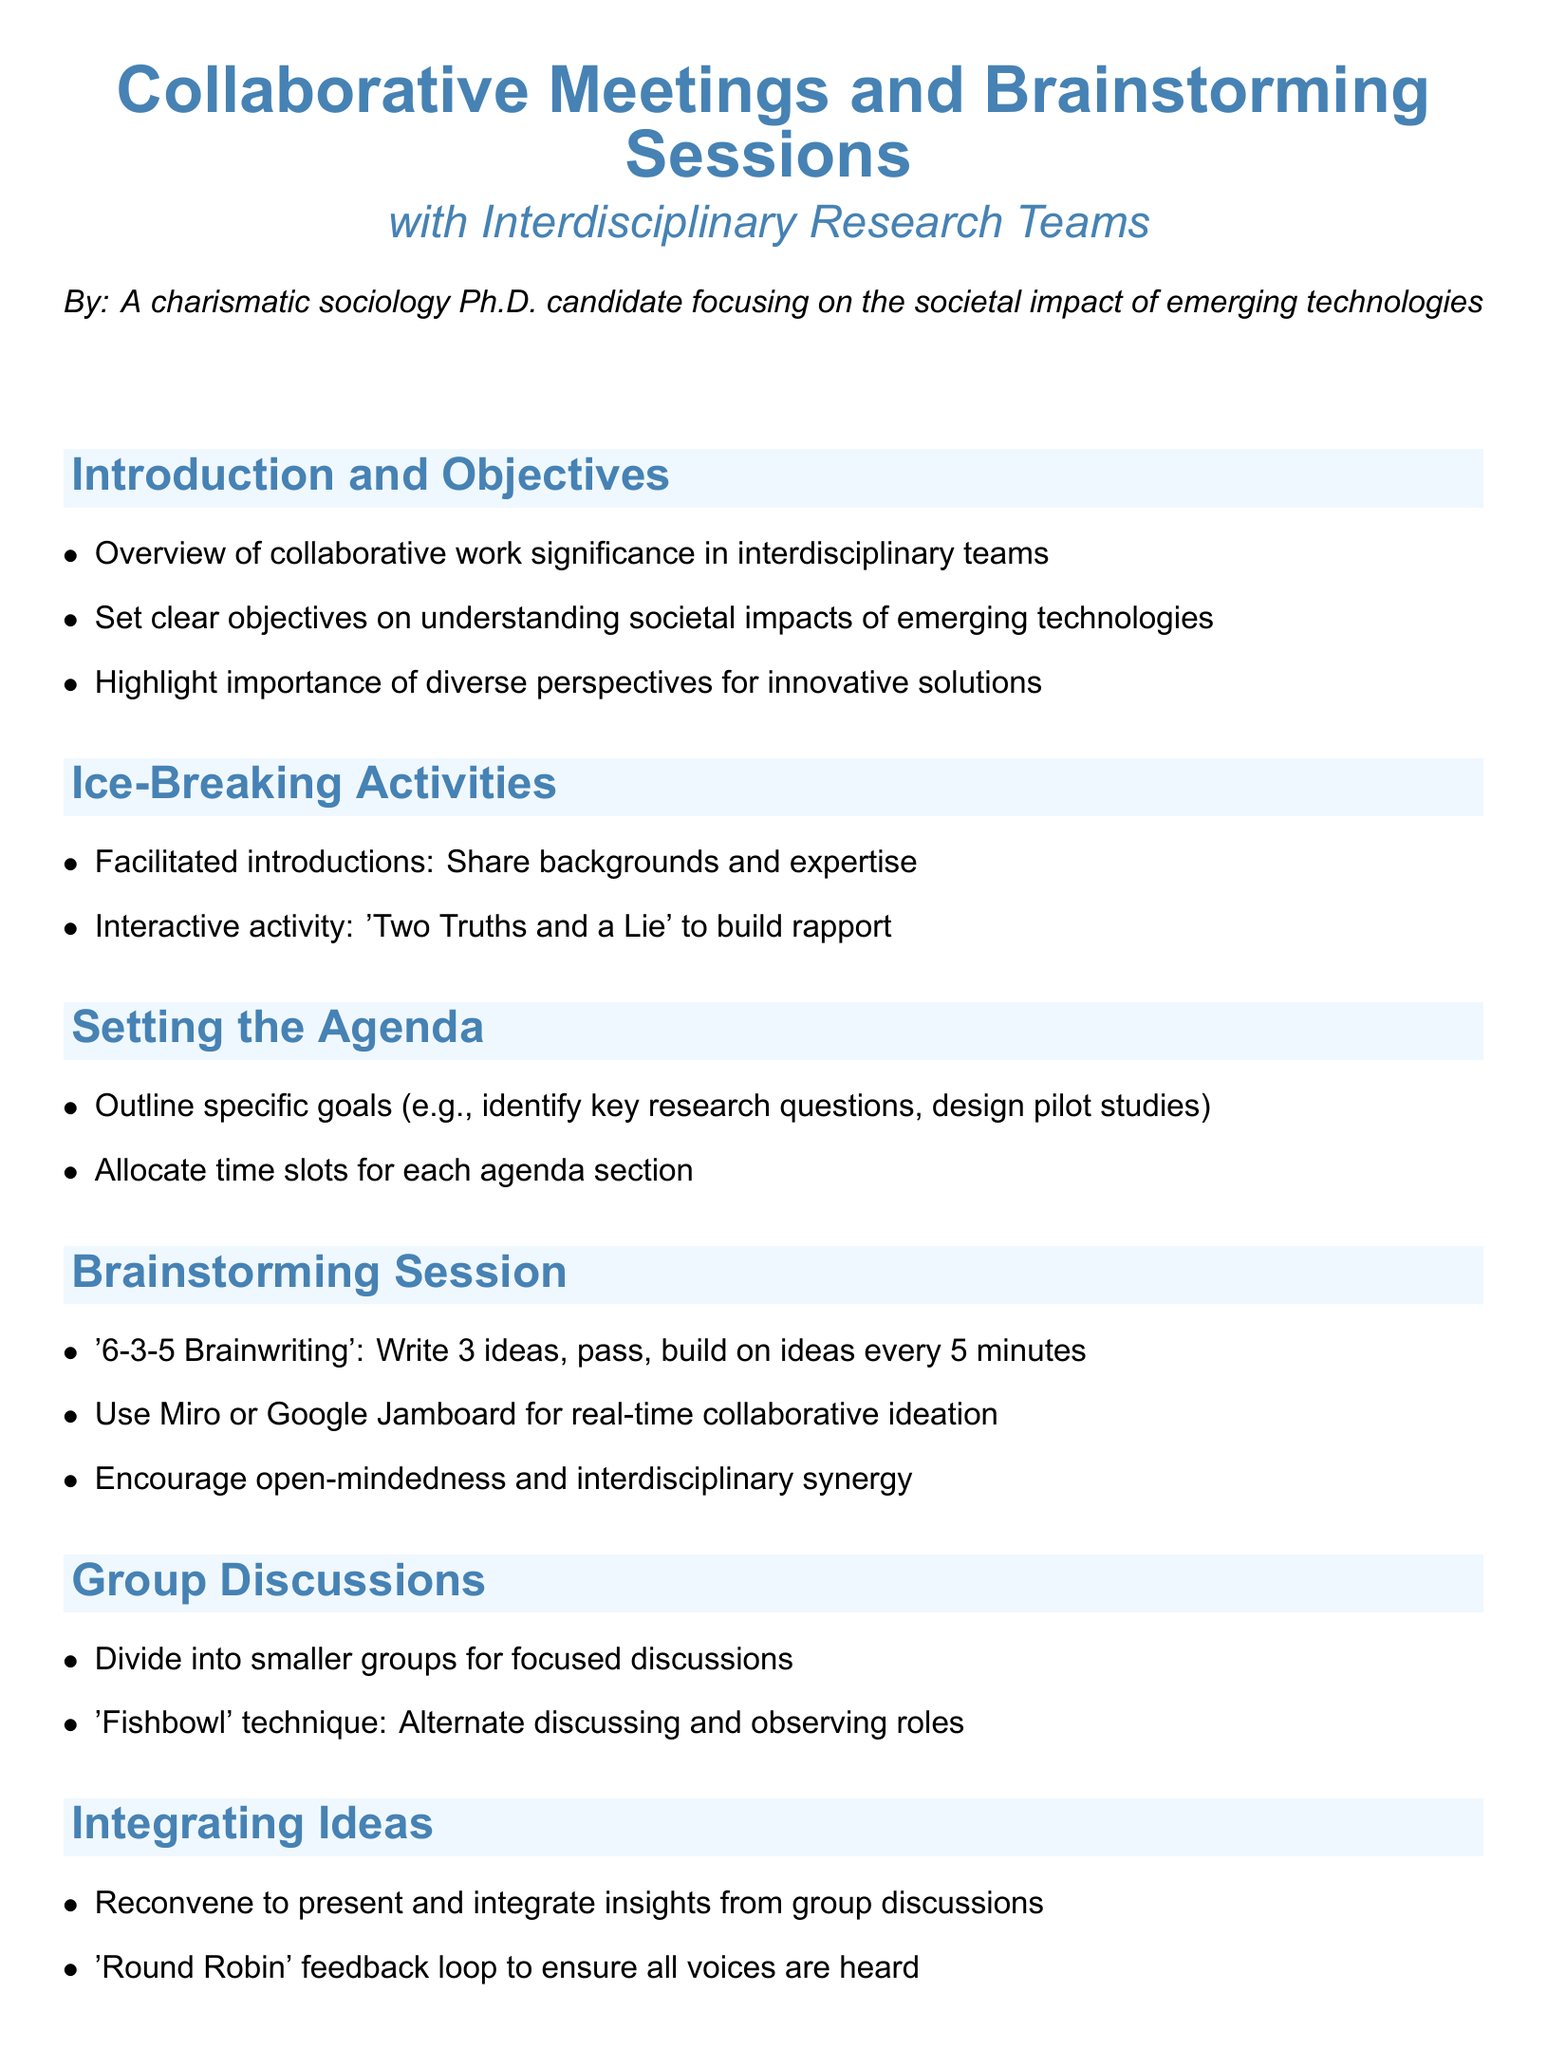What is the title of the document? The title is "Collaborative Meetings and Brainstorming Sessions."
Answer: Collaborative Meetings and Brainstorming Sessions Who is the author of the document? The author is identified at the beginning of the document.
Answer: A charismatic sociology Ph.D. candidate focusing on the societal impact of emerging technologies What is the first activity mentioned in the Ice-Breaking Activities section? The first activity listed under Ice-Breaking Activities is the facilitated introductions.
Answer: Facilitated introductions What technique is used for group discussions? The document describes a specific technique for group discussions in section titled Group Discussions.
Answer: Fishbowl What is the objective of the Action Plans and Next Steps section? The section discusses defining clear action items and responsibilities as part of the objectives.
Answer: Define clear action items and assign responsibilities How long do the ideas pass in the brainstorming session? The brainstorming session includes a specific time interval for passing ideas among participants.
Answer: Every 5 minutes What method is suggested for ongoing communication? The document mentions a specific tool for ongoing communication in the Action Plans and Next Steps section.
Answer: Slack or Trello What is emphasized in the Conclusion section regarding collaboration? The conclusion highlights an important aspect of the document concerning collaboration.
Answer: Importance of interdisciplinary collaboration 